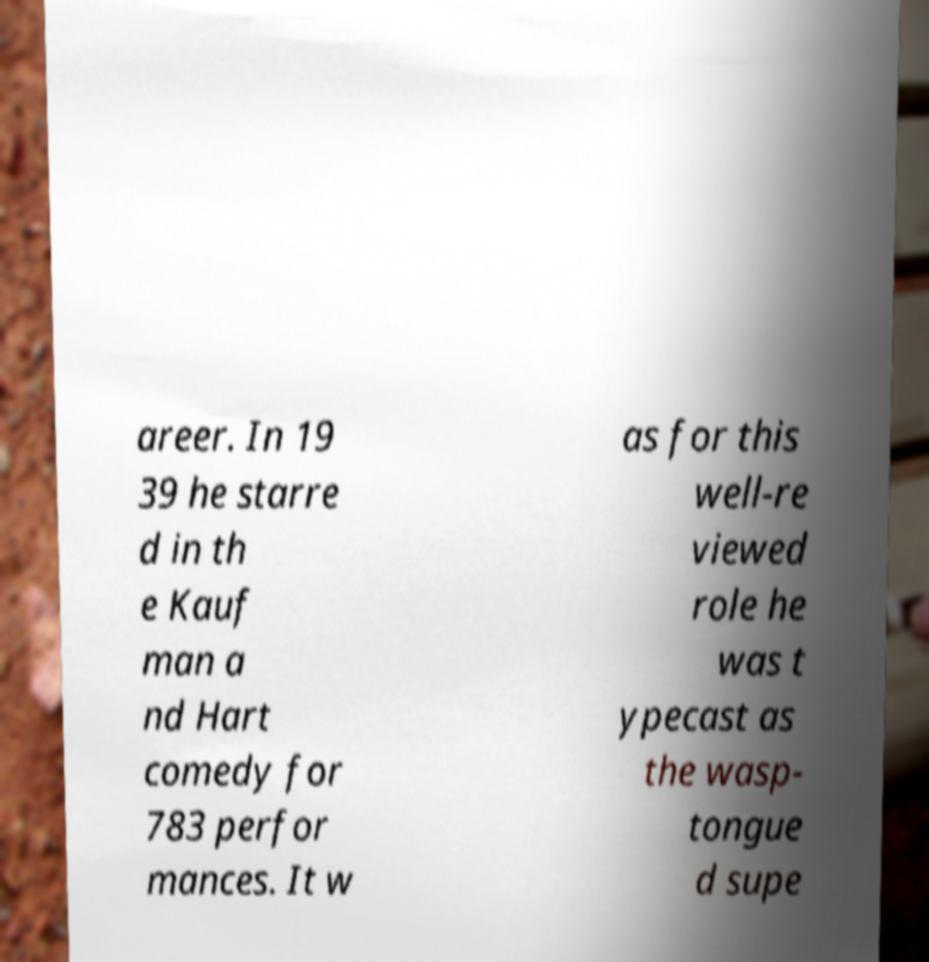There's text embedded in this image that I need extracted. Can you transcribe it verbatim? areer. In 19 39 he starre d in th e Kauf man a nd Hart comedy for 783 perfor mances. It w as for this well-re viewed role he was t ypecast as the wasp- tongue d supe 